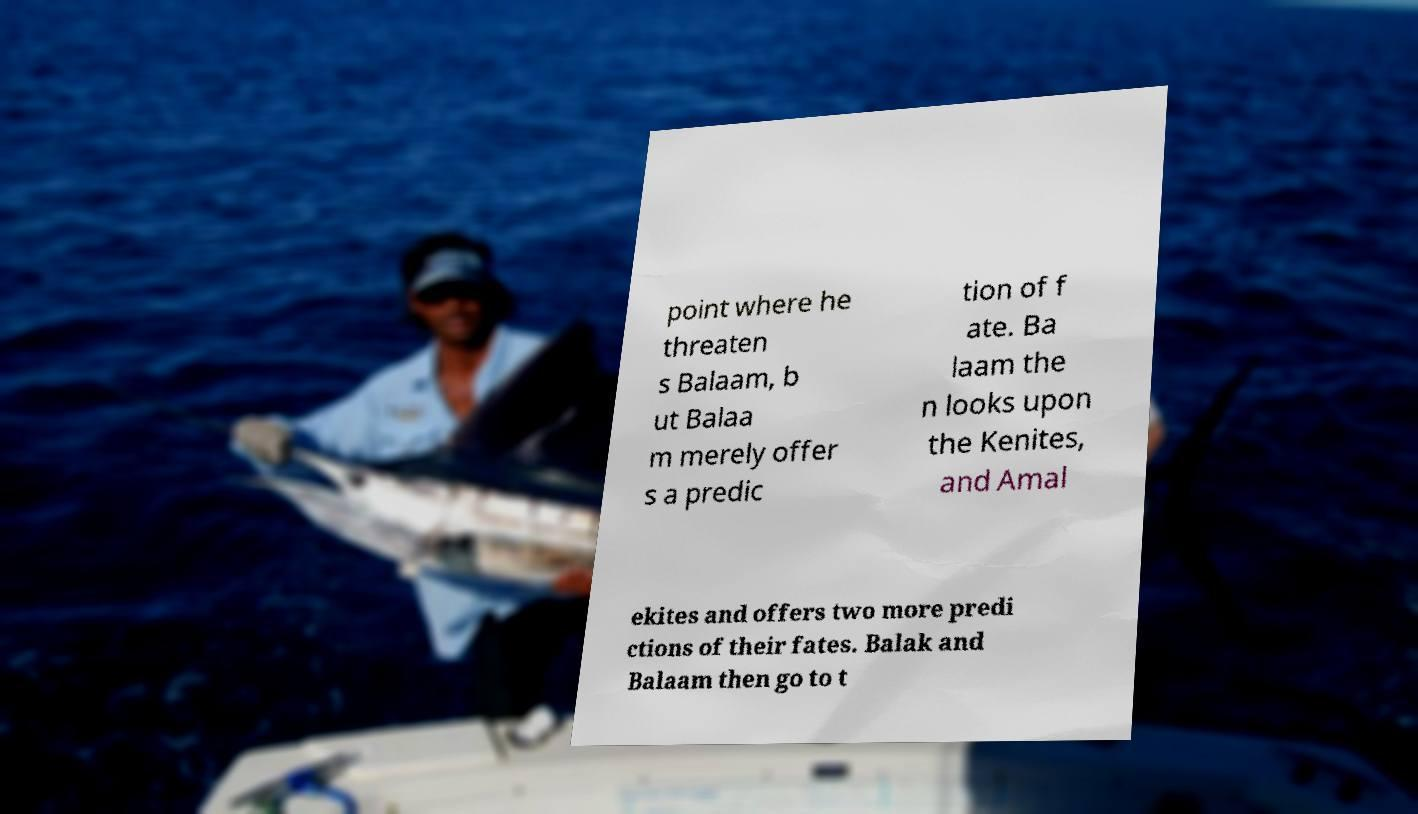I need the written content from this picture converted into text. Can you do that? point where he threaten s Balaam, b ut Balaa m merely offer s a predic tion of f ate. Ba laam the n looks upon the Kenites, and Amal ekites and offers two more predi ctions of their fates. Balak and Balaam then go to t 